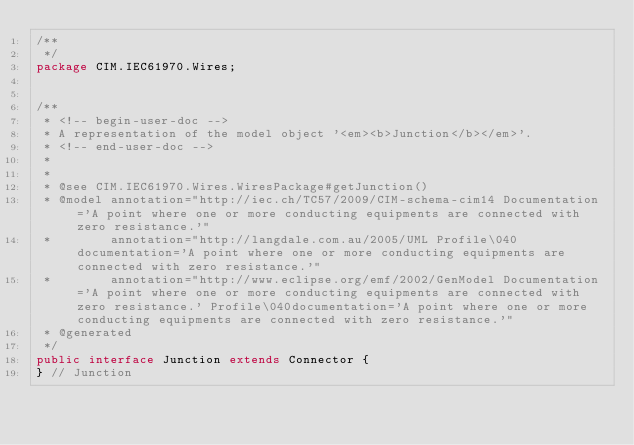Convert code to text. <code><loc_0><loc_0><loc_500><loc_500><_Java_>/**
 */
package CIM.IEC61970.Wires;


/**
 * <!-- begin-user-doc -->
 * A representation of the model object '<em><b>Junction</b></em>'.
 * <!-- end-user-doc -->
 *
 *
 * @see CIM.IEC61970.Wires.WiresPackage#getJunction()
 * @model annotation="http://iec.ch/TC57/2009/CIM-schema-cim14 Documentation='A point where one or more conducting equipments are connected with zero resistance.'"
 *        annotation="http://langdale.com.au/2005/UML Profile\040documentation='A point where one or more conducting equipments are connected with zero resistance.'"
 *        annotation="http://www.eclipse.org/emf/2002/GenModel Documentation='A point where one or more conducting equipments are connected with zero resistance.' Profile\040documentation='A point where one or more conducting equipments are connected with zero resistance.'"
 * @generated
 */
public interface Junction extends Connector {
} // Junction
</code> 